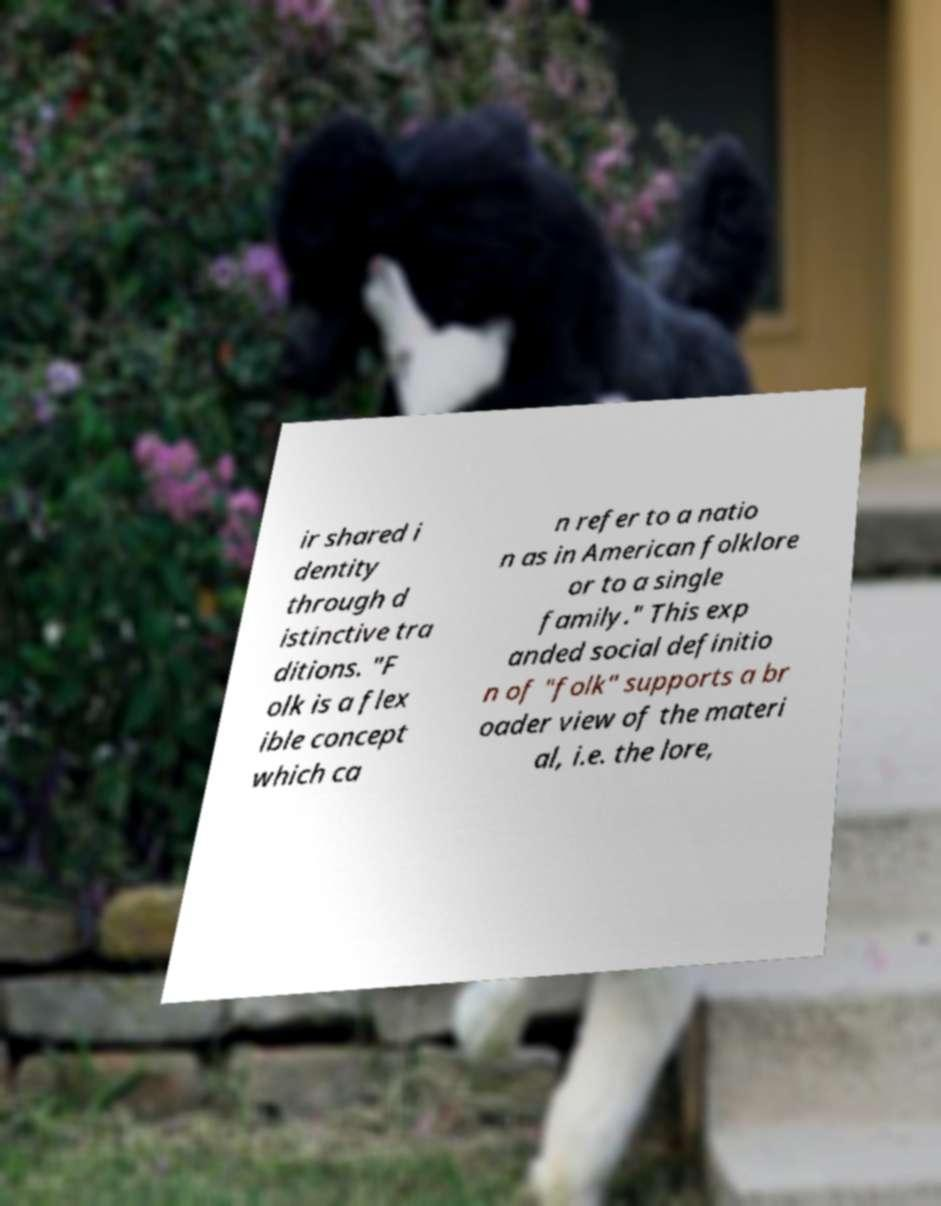I need the written content from this picture converted into text. Can you do that? ir shared i dentity through d istinctive tra ditions. "F olk is a flex ible concept which ca n refer to a natio n as in American folklore or to a single family." This exp anded social definitio n of "folk" supports a br oader view of the materi al, i.e. the lore, 